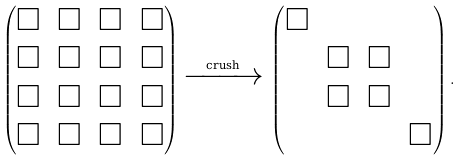<formula> <loc_0><loc_0><loc_500><loc_500>\begin{pmatrix} \Box & \Box & \Box & \Box \\ \Box & \Box & \Box & \Box \\ \Box & \Box & \Box & \Box \\ \Box & \Box & \Box & \Box \\ \end{pmatrix} \xrightarrow { \text {crush} } \, \begin{pmatrix} \Box & & & \\ & \Box & \Box & \\ & \Box & \Box & \\ & & & \Box \\ \end{pmatrix} .</formula> 